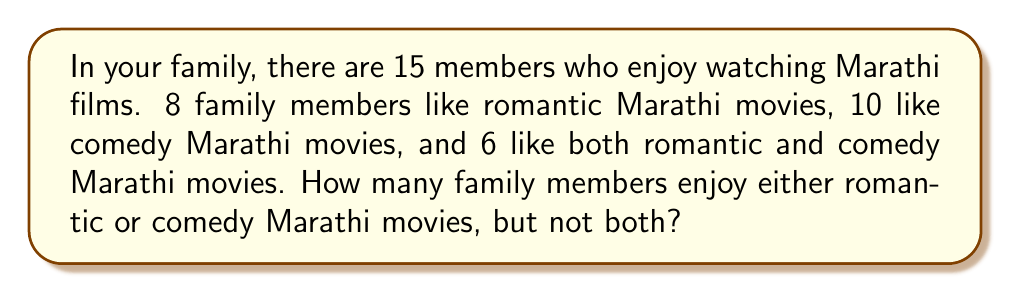What is the answer to this math problem? Let's approach this step-by-step using set theory:

1. Let R be the set of family members who like romantic Marathi movies.
2. Let C be the set of family members who like comedy Marathi movies.

We know:
- $|R| = 8$ (number of people who like romantic movies)
- $|C| = 10$ (number of people who like comedy movies)
- $|R \cap C| = 6$ (number of people who like both romantic and comedy movies)

We need to find the number of people who like either romantic or comedy movies, but not both. This is represented by the symmetric difference of sets R and C, denoted as $R \triangle C$.

The formula for symmetric difference is:
$$|R \triangle C| = |R \cup C| - |R \cap C|$$

To find $|R \cup C|$, we can use the inclusion-exclusion principle:
$$|R \cup C| = |R| + |C| - |R \cap C|$$

Substituting the values:
$$|R \cup C| = 8 + 10 - 6 = 12$$

Now we can calculate the symmetric difference:
$$|R \triangle C| = |R \cup C| - |R \cap C| = 12 - 6 = 6$$

Therefore, 6 family members enjoy either romantic or comedy Marathi movies, but not both.
Answer: 6 family members 